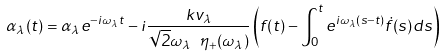Convert formula to latex. <formula><loc_0><loc_0><loc_500><loc_500>\alpha _ { \lambda } ( t ) = \alpha _ { \lambda } e ^ { - i \omega _ { \lambda } t } - i \frac { k v _ { \lambda } } { \sqrt { 2 } \omega _ { \lambda } \ \eta _ { + } ( \omega _ { \lambda } ) } \left ( f ( t ) - \int _ { 0 } ^ { t } e ^ { i \omega _ { \lambda } ( s - t ) } \dot { f } ( s ) d s \right )</formula> 